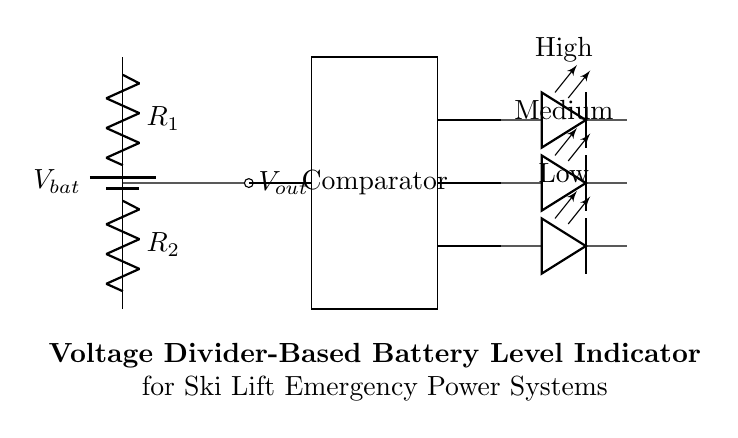What is the total voltage supplied by the battery? The battery is represented by the component labeled Vbat, which indicates that it is supplying a voltage. However, the specific value is not given in the circuit diagram; it simply states Vbat without a numerical value.
Answer: Vbat What components are involved in the voltage divider? The voltage divider consists of two resistors, labeled R1 and R2. These resistors are connected in series and are responsible for dividing the voltage from the battery.
Answer: R1, R2 What is the function of the comparator in this circuit? The comparator compares the output voltage, Vout, from the voltage divider to predefined reference levels to determine the battery's charge status. It generates an output signal that can drive the LED indicators based on the battery level.
Answer: Compare voltage levels How many LED indicators are present in the circuit? The circuit contains three LED indicators labeled High, Medium, and Low, which correspond to different battery charge levels as determined by the comparator outputs.
Answer: Three What is the relationship between R1, R2, and Vout? The output voltage Vout is determined by the voltage divider rule, which states that Vout = Vbat * (R2 / (R1 + R2)). This means that the output voltage is a fraction of the input voltage based on the resistor values.
Answer: Vout = Vbat * (R2 / (R1 + R2)) Which LED would light up if the battery voltage is considered low? If the battery voltage is low, the Low LED would light up. This is because the comparator will output a signal associated with a low voltage level, triggering the Low LED indicator to illuminate.
Answer: Low What happens to Vout when R1 is increased while keeping R2 constant? Increasing R1 while keeping R2 constant would decrease Vout since a larger R1 provides a greater voltage drop across it, leading to a smaller fraction of Vbat being present at Vout.
Answer: Vout decreases 